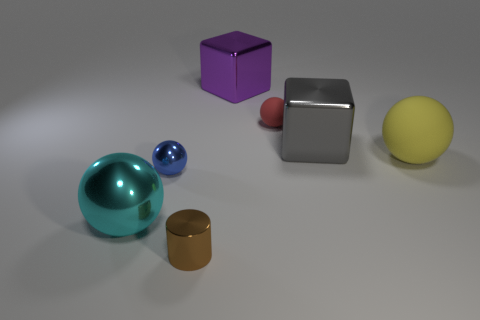Subtract all cyan balls. How many balls are left? 3 Add 1 large yellow metallic blocks. How many objects exist? 8 Subtract all red spheres. How many spheres are left? 3 Subtract all blocks. How many objects are left? 5 Subtract 1 balls. How many balls are left? 3 Subtract 1 cyan spheres. How many objects are left? 6 Subtract all cyan balls. Subtract all cyan blocks. How many balls are left? 3 Subtract all tiny purple metallic things. Subtract all purple blocks. How many objects are left? 6 Add 5 large objects. How many large objects are left? 9 Add 3 yellow balls. How many yellow balls exist? 4 